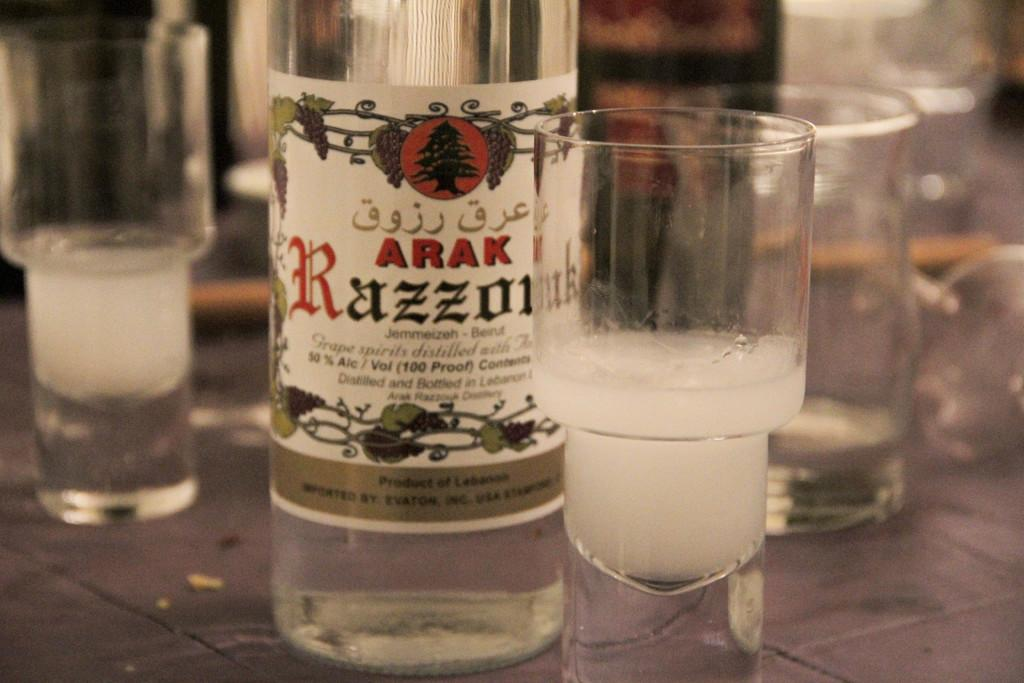What type of container is visible in the image? There is a glass bottle in the image. What other objects are near the glass bottle? There are glasses beside the glass bottle in the image. What type of appliance can be seen in the image? There is no appliance present in the image. Can you spot a bee buzzing around the glass bottle in the image? There is no bee present in the image. 